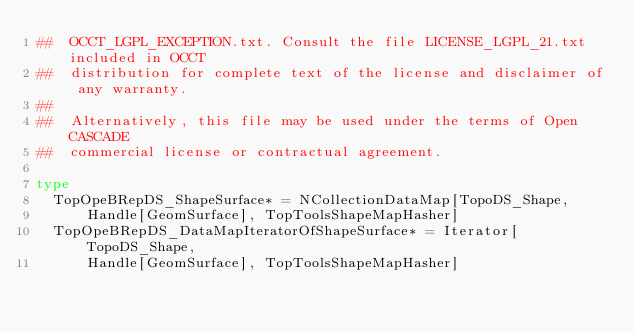<code> <loc_0><loc_0><loc_500><loc_500><_Nim_>##  OCCT_LGPL_EXCEPTION.txt. Consult the file LICENSE_LGPL_21.txt included in OCCT
##  distribution for complete text of the license and disclaimer of any warranty.
##
##  Alternatively, this file may be used under the terms of Open CASCADE
##  commercial license or contractual agreement.

type
  TopOpeBRepDS_ShapeSurface* = NCollectionDataMap[TopoDS_Shape,
      Handle[GeomSurface], TopToolsShapeMapHasher]
  TopOpeBRepDS_DataMapIteratorOfShapeSurface* = Iterator[TopoDS_Shape,
      Handle[GeomSurface], TopToolsShapeMapHasher]
</code> 